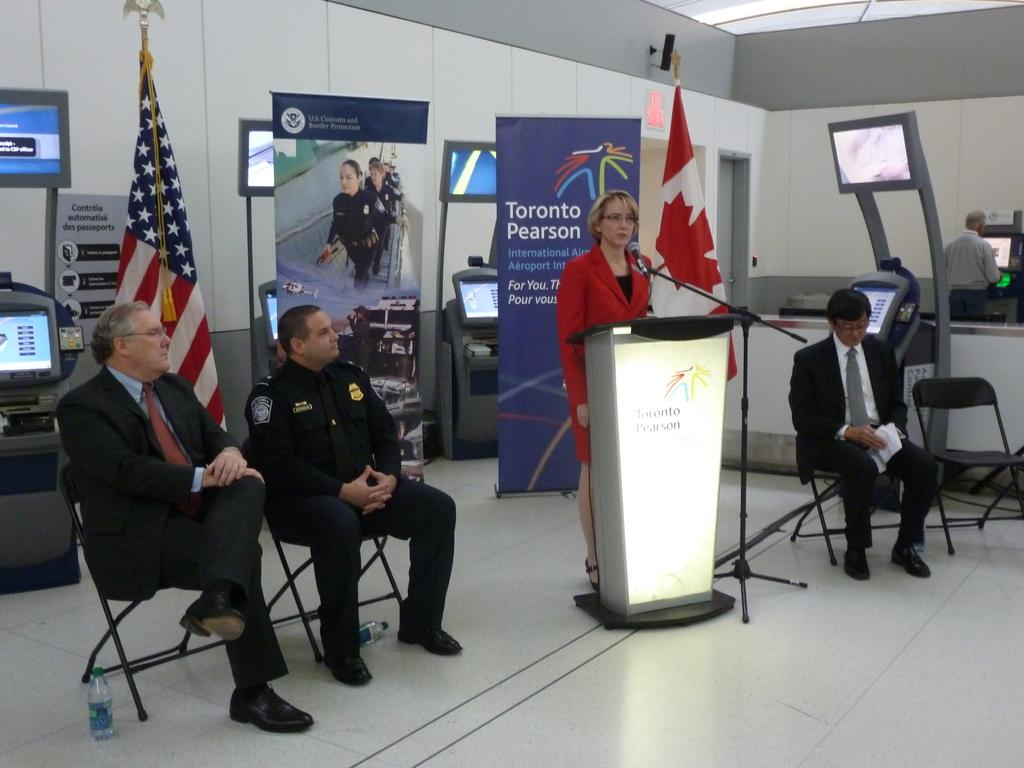<image>
Render a clear and concise summary of the photo. A woman stands at a podium in front of a sign that says Toronto Pearson. 